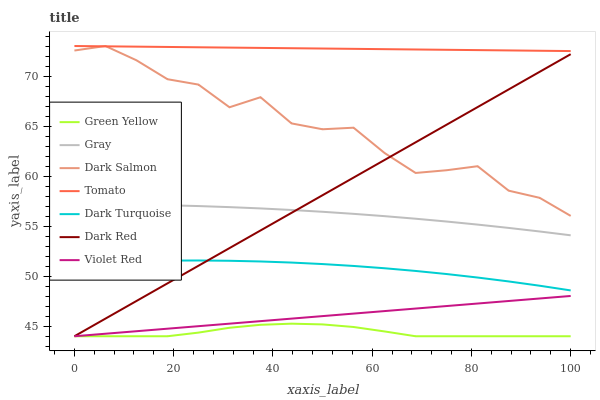Does Gray have the minimum area under the curve?
Answer yes or no. No. Does Gray have the maximum area under the curve?
Answer yes or no. No. Is Gray the smoothest?
Answer yes or no. No. Is Gray the roughest?
Answer yes or no. No. Does Gray have the lowest value?
Answer yes or no. No. Does Gray have the highest value?
Answer yes or no. No. Is Dark Turquoise less than Dark Salmon?
Answer yes or no. Yes. Is Tomato greater than Green Yellow?
Answer yes or no. Yes. Does Dark Turquoise intersect Dark Salmon?
Answer yes or no. No. 